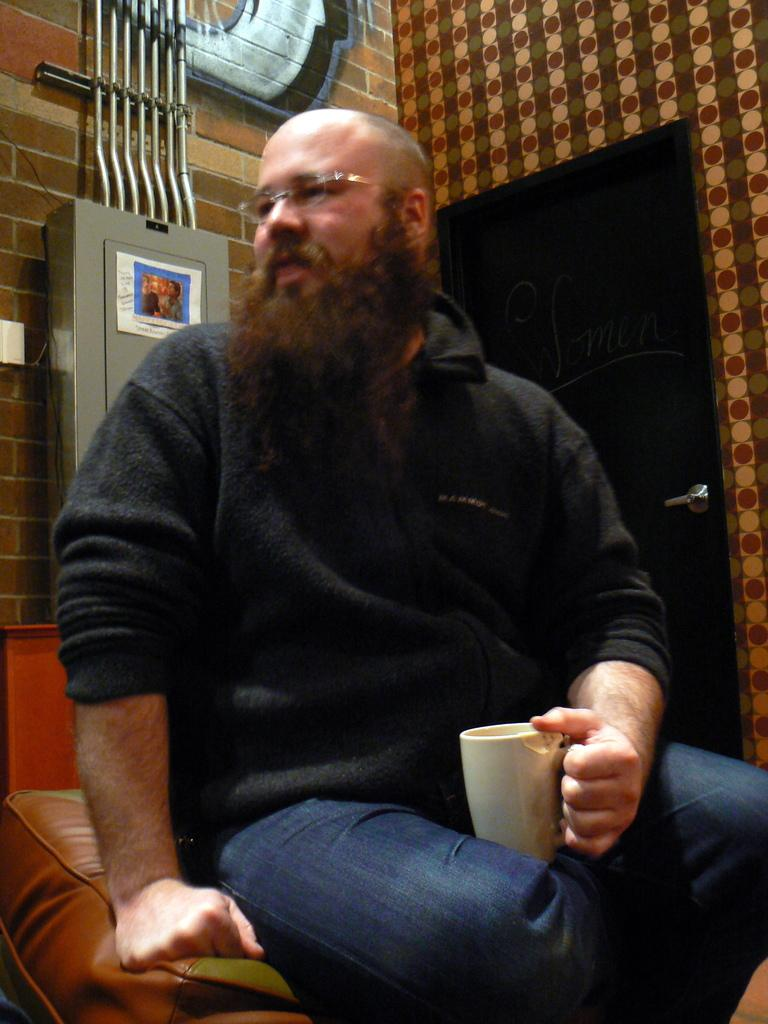Who is present in the image? There is a man in the image. What is the man holding in the image? The man is holding a white cup. Can you describe the man's appearance? The man is wearing spectacles. What can be seen in the background of the image? There is a door and a wall in the background of the image. How many buns are on the man's head in the image? There are no buns present on the man's head in the image. What color are the man's eyes in the image? The provided facts do not mention the color of the man's eyes, so we cannot determine that information from the image. 